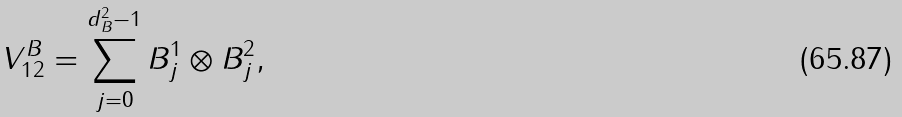<formula> <loc_0><loc_0><loc_500><loc_500>V _ { 1 2 } ^ { B } = \sum _ { j = 0 } ^ { d _ { B } ^ { 2 } - 1 } B _ { j } ^ { 1 } \otimes B _ { j } ^ { 2 } ,</formula> 